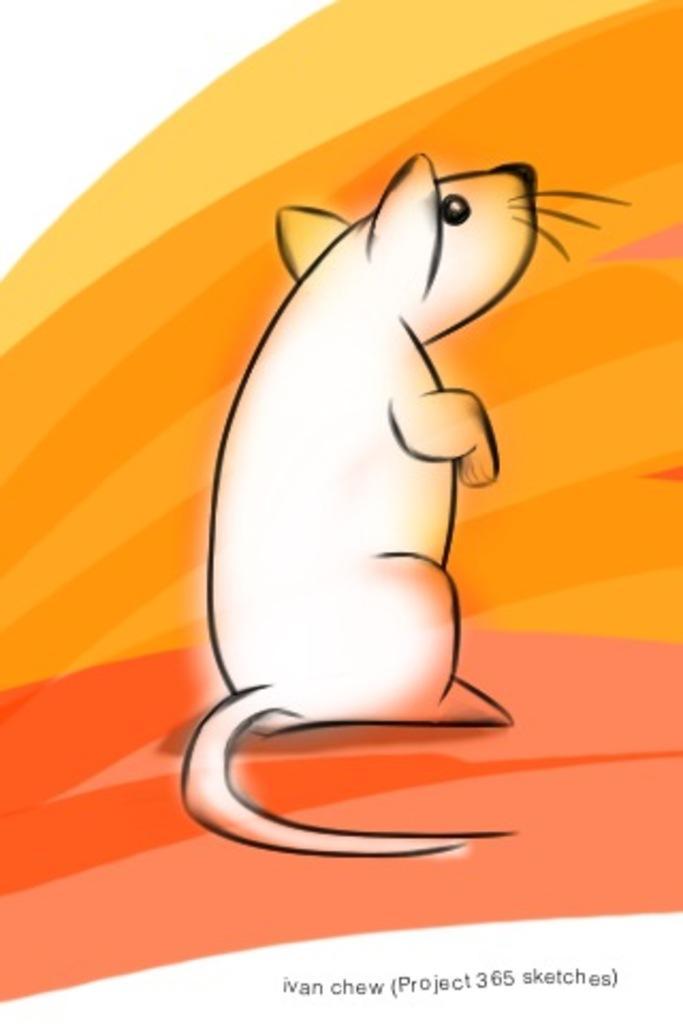In one or two sentences, can you explain what this image depicts? In this image in the center there is graphical image of the animal. 